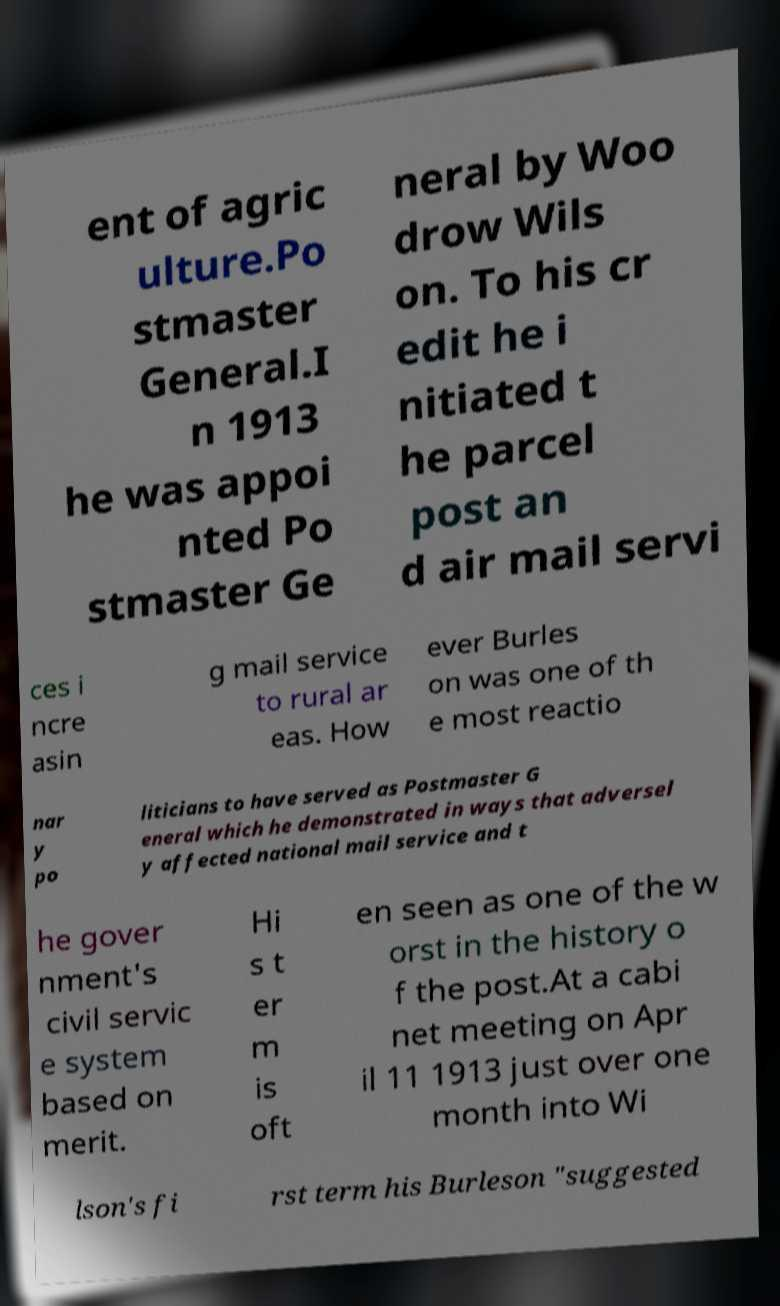There's text embedded in this image that I need extracted. Can you transcribe it verbatim? ent of agric ulture.Po stmaster General.I n 1913 he was appoi nted Po stmaster Ge neral by Woo drow Wils on. To his cr edit he i nitiated t he parcel post an d air mail servi ces i ncre asin g mail service to rural ar eas. How ever Burles on was one of th e most reactio nar y po liticians to have served as Postmaster G eneral which he demonstrated in ways that adversel y affected national mail service and t he gover nment's civil servic e system based on merit. Hi s t er m is oft en seen as one of the w orst in the history o f the post.At a cabi net meeting on Apr il 11 1913 just over one month into Wi lson's fi rst term his Burleson "suggested 